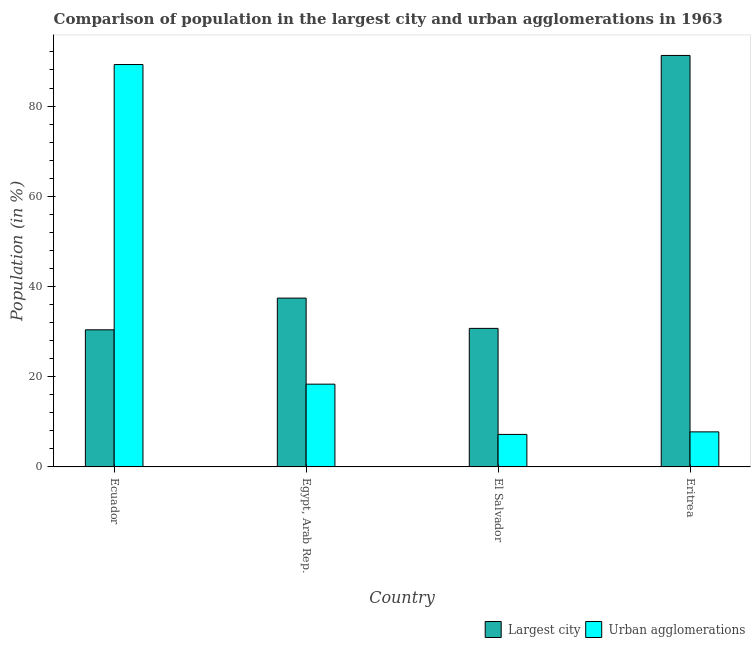How many bars are there on the 1st tick from the left?
Offer a very short reply. 2. How many bars are there on the 1st tick from the right?
Offer a very short reply. 2. What is the label of the 2nd group of bars from the left?
Provide a succinct answer. Egypt, Arab Rep. In how many cases, is the number of bars for a given country not equal to the number of legend labels?
Provide a succinct answer. 0. What is the population in the largest city in El Salvador?
Provide a short and direct response. 30.72. Across all countries, what is the maximum population in urban agglomerations?
Offer a very short reply. 89.21. Across all countries, what is the minimum population in urban agglomerations?
Provide a short and direct response. 7.21. In which country was the population in the largest city maximum?
Offer a very short reply. Eritrea. In which country was the population in the largest city minimum?
Offer a terse response. Ecuador. What is the total population in urban agglomerations in the graph?
Offer a terse response. 122.54. What is the difference between the population in the largest city in Ecuador and that in Egypt, Arab Rep.?
Your answer should be very brief. -7.03. What is the difference between the population in urban agglomerations in Eritrea and the population in the largest city in Egypt, Arab Rep.?
Your answer should be very brief. -29.66. What is the average population in urban agglomerations per country?
Ensure brevity in your answer.  30.63. What is the difference between the population in the largest city and population in urban agglomerations in El Salvador?
Your answer should be very brief. 23.51. What is the ratio of the population in urban agglomerations in Egypt, Arab Rep. to that in Eritrea?
Provide a succinct answer. 2.36. What is the difference between the highest and the second highest population in the largest city?
Give a very brief answer. 53.79. What is the difference between the highest and the lowest population in urban agglomerations?
Your answer should be very brief. 82. In how many countries, is the population in urban agglomerations greater than the average population in urban agglomerations taken over all countries?
Ensure brevity in your answer.  1. Is the sum of the population in the largest city in Egypt, Arab Rep. and Eritrea greater than the maximum population in urban agglomerations across all countries?
Your answer should be very brief. Yes. What does the 1st bar from the left in El Salvador represents?
Provide a short and direct response. Largest city. What does the 2nd bar from the right in El Salvador represents?
Offer a very short reply. Largest city. Are all the bars in the graph horizontal?
Ensure brevity in your answer.  No. What is the difference between two consecutive major ticks on the Y-axis?
Offer a terse response. 20. Does the graph contain any zero values?
Offer a very short reply. No. How many legend labels are there?
Give a very brief answer. 2. What is the title of the graph?
Keep it short and to the point. Comparison of population in the largest city and urban agglomerations in 1963. Does "Secondary education" appear as one of the legend labels in the graph?
Make the answer very short. No. What is the label or title of the Y-axis?
Ensure brevity in your answer.  Population (in %). What is the Population (in %) in Largest city in Ecuador?
Keep it short and to the point. 30.4. What is the Population (in %) in Urban agglomerations in Ecuador?
Your answer should be compact. 89.21. What is the Population (in %) in Largest city in Egypt, Arab Rep.?
Give a very brief answer. 37.43. What is the Population (in %) in Urban agglomerations in Egypt, Arab Rep.?
Offer a very short reply. 18.35. What is the Population (in %) of Largest city in El Salvador?
Your answer should be compact. 30.72. What is the Population (in %) of Urban agglomerations in El Salvador?
Ensure brevity in your answer.  7.21. What is the Population (in %) of Largest city in Eritrea?
Keep it short and to the point. 91.22. What is the Population (in %) of Urban agglomerations in Eritrea?
Provide a succinct answer. 7.77. Across all countries, what is the maximum Population (in %) of Largest city?
Provide a short and direct response. 91.22. Across all countries, what is the maximum Population (in %) in Urban agglomerations?
Give a very brief answer. 89.21. Across all countries, what is the minimum Population (in %) of Largest city?
Your response must be concise. 30.4. Across all countries, what is the minimum Population (in %) of Urban agglomerations?
Your answer should be very brief. 7.21. What is the total Population (in %) of Largest city in the graph?
Provide a succinct answer. 189.77. What is the total Population (in %) of Urban agglomerations in the graph?
Provide a succinct answer. 122.54. What is the difference between the Population (in %) in Largest city in Ecuador and that in Egypt, Arab Rep.?
Ensure brevity in your answer.  -7.03. What is the difference between the Population (in %) in Urban agglomerations in Ecuador and that in Egypt, Arab Rep.?
Keep it short and to the point. 70.86. What is the difference between the Population (in %) in Largest city in Ecuador and that in El Salvador?
Provide a short and direct response. -0.32. What is the difference between the Population (in %) of Urban agglomerations in Ecuador and that in El Salvador?
Make the answer very short. 82. What is the difference between the Population (in %) in Largest city in Ecuador and that in Eritrea?
Keep it short and to the point. -60.82. What is the difference between the Population (in %) of Urban agglomerations in Ecuador and that in Eritrea?
Give a very brief answer. 81.43. What is the difference between the Population (in %) of Largest city in Egypt, Arab Rep. and that in El Salvador?
Your answer should be compact. 6.71. What is the difference between the Population (in %) of Urban agglomerations in Egypt, Arab Rep. and that in El Salvador?
Your response must be concise. 11.14. What is the difference between the Population (in %) of Largest city in Egypt, Arab Rep. and that in Eritrea?
Give a very brief answer. -53.79. What is the difference between the Population (in %) of Urban agglomerations in Egypt, Arab Rep. and that in Eritrea?
Your response must be concise. 10.57. What is the difference between the Population (in %) in Largest city in El Salvador and that in Eritrea?
Your answer should be compact. -60.51. What is the difference between the Population (in %) of Urban agglomerations in El Salvador and that in Eritrea?
Your answer should be very brief. -0.57. What is the difference between the Population (in %) in Largest city in Ecuador and the Population (in %) in Urban agglomerations in Egypt, Arab Rep.?
Keep it short and to the point. 12.05. What is the difference between the Population (in %) in Largest city in Ecuador and the Population (in %) in Urban agglomerations in El Salvador?
Offer a very short reply. 23.19. What is the difference between the Population (in %) of Largest city in Ecuador and the Population (in %) of Urban agglomerations in Eritrea?
Keep it short and to the point. 22.63. What is the difference between the Population (in %) in Largest city in Egypt, Arab Rep. and the Population (in %) in Urban agglomerations in El Salvador?
Offer a terse response. 30.22. What is the difference between the Population (in %) in Largest city in Egypt, Arab Rep. and the Population (in %) in Urban agglomerations in Eritrea?
Your answer should be very brief. 29.66. What is the difference between the Population (in %) of Largest city in El Salvador and the Population (in %) of Urban agglomerations in Eritrea?
Offer a very short reply. 22.94. What is the average Population (in %) in Largest city per country?
Provide a succinct answer. 47.44. What is the average Population (in %) of Urban agglomerations per country?
Your answer should be very brief. 30.63. What is the difference between the Population (in %) of Largest city and Population (in %) of Urban agglomerations in Ecuador?
Your answer should be compact. -58.81. What is the difference between the Population (in %) in Largest city and Population (in %) in Urban agglomerations in Egypt, Arab Rep.?
Offer a very short reply. 19.08. What is the difference between the Population (in %) in Largest city and Population (in %) in Urban agglomerations in El Salvador?
Your answer should be very brief. 23.51. What is the difference between the Population (in %) in Largest city and Population (in %) in Urban agglomerations in Eritrea?
Offer a very short reply. 83.45. What is the ratio of the Population (in %) in Largest city in Ecuador to that in Egypt, Arab Rep.?
Provide a short and direct response. 0.81. What is the ratio of the Population (in %) in Urban agglomerations in Ecuador to that in Egypt, Arab Rep.?
Provide a short and direct response. 4.86. What is the ratio of the Population (in %) in Largest city in Ecuador to that in El Salvador?
Provide a short and direct response. 0.99. What is the ratio of the Population (in %) in Urban agglomerations in Ecuador to that in El Salvador?
Your response must be concise. 12.38. What is the ratio of the Population (in %) in Largest city in Ecuador to that in Eritrea?
Your response must be concise. 0.33. What is the ratio of the Population (in %) in Urban agglomerations in Ecuador to that in Eritrea?
Provide a short and direct response. 11.48. What is the ratio of the Population (in %) in Largest city in Egypt, Arab Rep. to that in El Salvador?
Offer a very short reply. 1.22. What is the ratio of the Population (in %) of Urban agglomerations in Egypt, Arab Rep. to that in El Salvador?
Ensure brevity in your answer.  2.55. What is the ratio of the Population (in %) of Largest city in Egypt, Arab Rep. to that in Eritrea?
Ensure brevity in your answer.  0.41. What is the ratio of the Population (in %) in Urban agglomerations in Egypt, Arab Rep. to that in Eritrea?
Provide a succinct answer. 2.36. What is the ratio of the Population (in %) in Largest city in El Salvador to that in Eritrea?
Offer a very short reply. 0.34. What is the ratio of the Population (in %) in Urban agglomerations in El Salvador to that in Eritrea?
Give a very brief answer. 0.93. What is the difference between the highest and the second highest Population (in %) of Largest city?
Keep it short and to the point. 53.79. What is the difference between the highest and the second highest Population (in %) in Urban agglomerations?
Offer a terse response. 70.86. What is the difference between the highest and the lowest Population (in %) of Largest city?
Give a very brief answer. 60.82. What is the difference between the highest and the lowest Population (in %) of Urban agglomerations?
Provide a succinct answer. 82. 